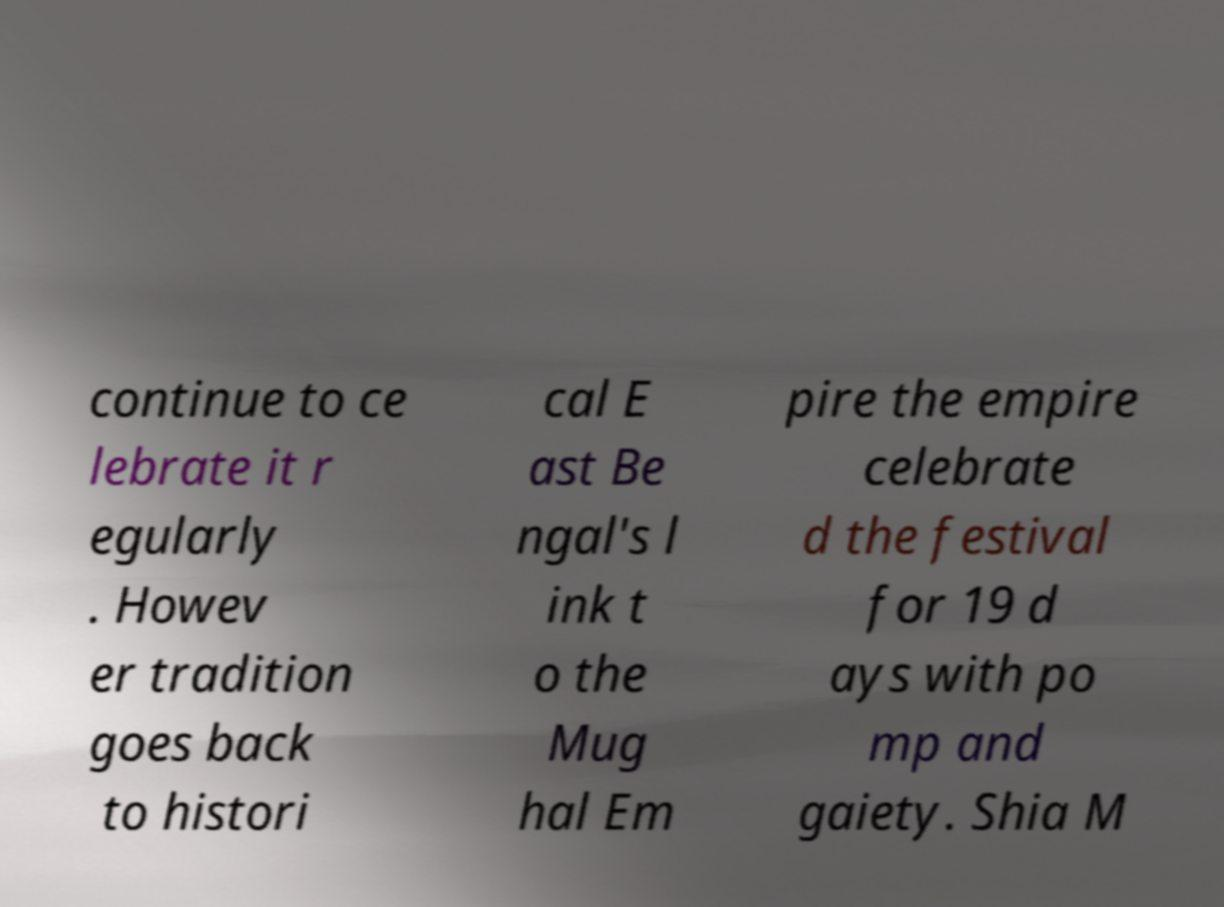Can you read and provide the text displayed in the image?This photo seems to have some interesting text. Can you extract and type it out for me? continue to ce lebrate it r egularly . Howev er tradition goes back to histori cal E ast Be ngal's l ink t o the Mug hal Em pire the empire celebrate d the festival for 19 d ays with po mp and gaiety. Shia M 